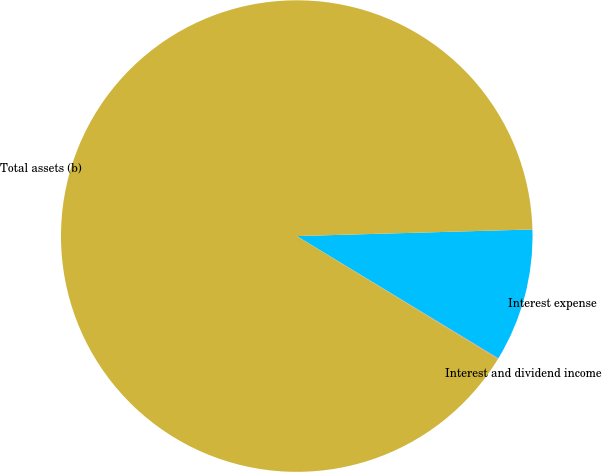Convert chart. <chart><loc_0><loc_0><loc_500><loc_500><pie_chart><fcel>Interest and dividend income<fcel>Interest expense<fcel>Total assets (b)<nl><fcel>0.05%<fcel>9.12%<fcel>90.83%<nl></chart> 